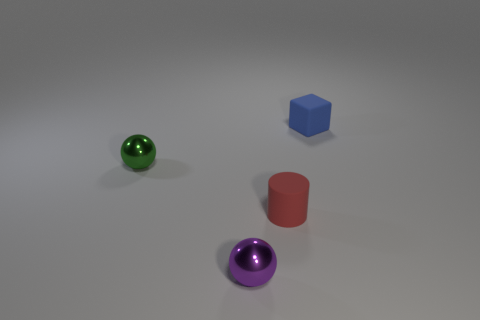Add 2 tiny purple matte objects. How many objects exist? 6 Subtract all brown spheres. Subtract all gray cubes. How many spheres are left? 2 Subtract all green cubes. How many blue balls are left? 0 Subtract all purple shiny objects. Subtract all tiny rubber things. How many objects are left? 1 Add 1 red matte cylinders. How many red matte cylinders are left? 2 Add 2 cubes. How many cubes exist? 3 Subtract all purple spheres. How many spheres are left? 1 Subtract 0 blue spheres. How many objects are left? 4 Subtract all cubes. How many objects are left? 3 Subtract 1 cylinders. How many cylinders are left? 0 